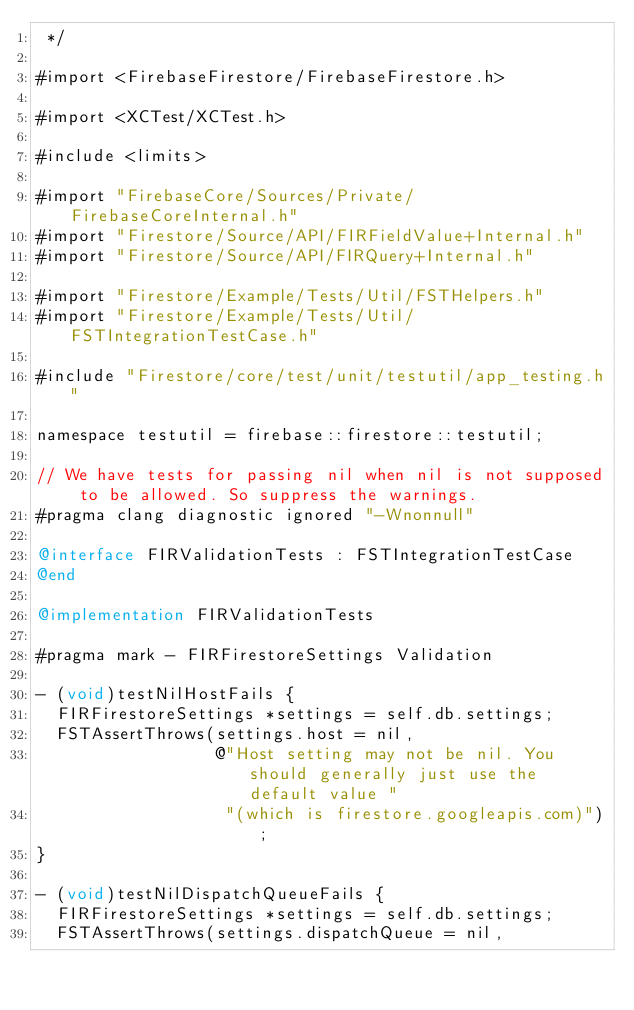Convert code to text. <code><loc_0><loc_0><loc_500><loc_500><_ObjectiveC_> */

#import <FirebaseFirestore/FirebaseFirestore.h>

#import <XCTest/XCTest.h>

#include <limits>

#import "FirebaseCore/Sources/Private/FirebaseCoreInternal.h"
#import "Firestore/Source/API/FIRFieldValue+Internal.h"
#import "Firestore/Source/API/FIRQuery+Internal.h"

#import "Firestore/Example/Tests/Util/FSTHelpers.h"
#import "Firestore/Example/Tests/Util/FSTIntegrationTestCase.h"

#include "Firestore/core/test/unit/testutil/app_testing.h"

namespace testutil = firebase::firestore::testutil;

// We have tests for passing nil when nil is not supposed to be allowed. So suppress the warnings.
#pragma clang diagnostic ignored "-Wnonnull"

@interface FIRValidationTests : FSTIntegrationTestCase
@end

@implementation FIRValidationTests

#pragma mark - FIRFirestoreSettings Validation

- (void)testNilHostFails {
  FIRFirestoreSettings *settings = self.db.settings;
  FSTAssertThrows(settings.host = nil,
                  @"Host setting may not be nil. You should generally just use the default value "
                   "(which is firestore.googleapis.com)");
}

- (void)testNilDispatchQueueFails {
  FIRFirestoreSettings *settings = self.db.settings;
  FSTAssertThrows(settings.dispatchQueue = nil,</code> 